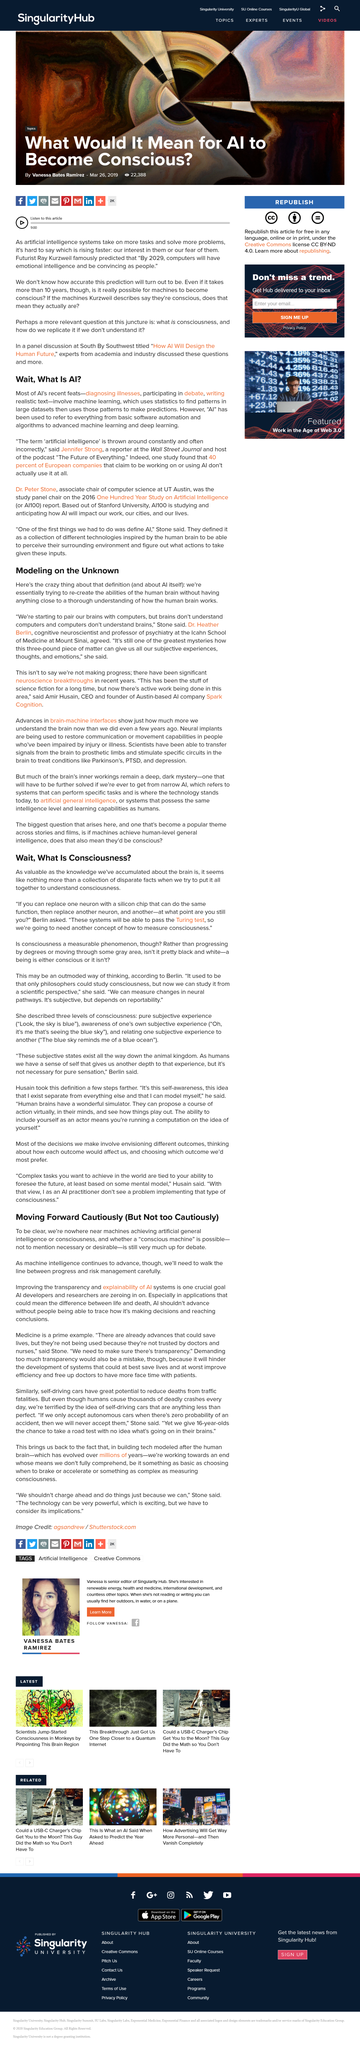Indicate a few pertinent items in this graphic. Artificial general intelligence and consciousness are still far from being achieved by AI developers. Machine learning uses statistics to find patterns and make predictions by analyzing large datasets. The article mentions replacing one neuron with a silicon chip. Artificial intelligence has been used to diagnose illnesses and participate in debates. The Turing test is a widely recognized and influential test of a machine's ability to demonstrate intelligent behavior that is equivalent to, or indistinguishable from, that of a human. 